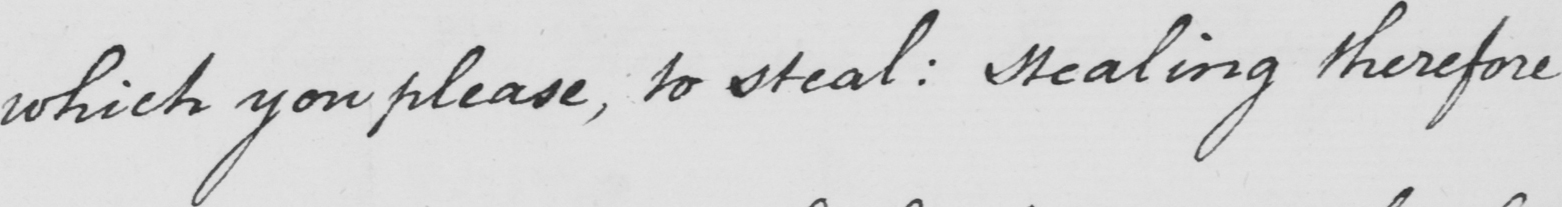Transcribe the text shown in this historical manuscript line. which you please , to steal :  stealing therefore 